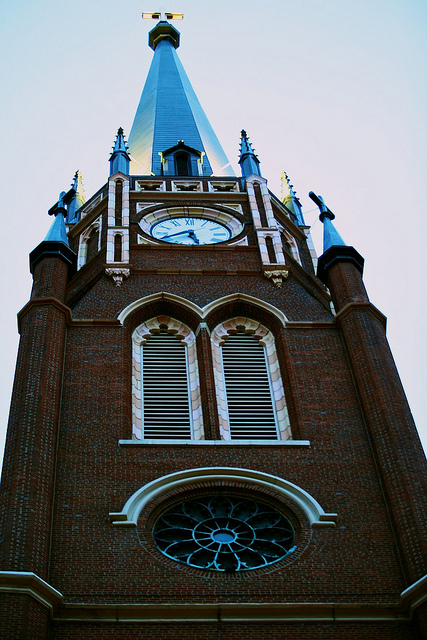<image>What country is this? I am not sure about the country. It may be England or United Kingdom. What country is this? I am not sure what country this is. It can be either England or United Kingdom. 